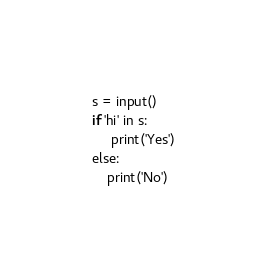<code> <loc_0><loc_0><loc_500><loc_500><_C++_>s = input()
if 'hi' in s:
     print('Yes')
else:
    print('No')</code> 